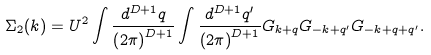Convert formula to latex. <formula><loc_0><loc_0><loc_500><loc_500>\Sigma _ { 2 } ( k ) = U ^ { 2 } \int \frac { d ^ { D + 1 } q } { \left ( 2 \pi \right ) ^ { D + 1 } } \int \frac { d ^ { D + 1 } q ^ { \prime } } { \left ( 2 \pi \right ) ^ { D + 1 } } G _ { k + q } G _ { - k + q ^ { \prime } } G _ { - k + q + q ^ { \prime } } .</formula> 